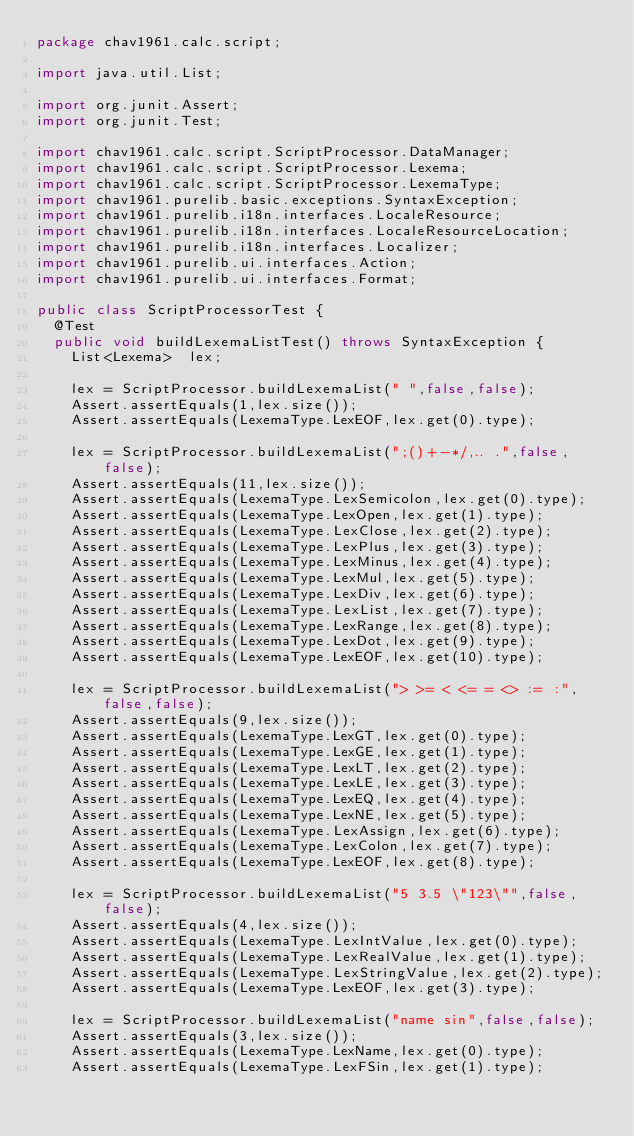<code> <loc_0><loc_0><loc_500><loc_500><_Java_>package chav1961.calc.script;

import java.util.List;

import org.junit.Assert;
import org.junit.Test;

import chav1961.calc.script.ScriptProcessor.DataManager;
import chav1961.calc.script.ScriptProcessor.Lexema;
import chav1961.calc.script.ScriptProcessor.LexemaType;
import chav1961.purelib.basic.exceptions.SyntaxException;
import chav1961.purelib.i18n.interfaces.LocaleResource;
import chav1961.purelib.i18n.interfaces.LocaleResourceLocation;
import chav1961.purelib.i18n.interfaces.Localizer;
import chav1961.purelib.ui.interfaces.Action;
import chav1961.purelib.ui.interfaces.Format;

public class ScriptProcessorTest {
	@Test
	public void buildLexemaListTest() throws SyntaxException {
		List<Lexema>	lex;
		
		lex = ScriptProcessor.buildLexemaList(" ",false,false);
		Assert.assertEquals(1,lex.size());
		Assert.assertEquals(LexemaType.LexEOF,lex.get(0).type);

		lex = ScriptProcessor.buildLexemaList(";()+-*/,.. .",false,false);
		Assert.assertEquals(11,lex.size());
		Assert.assertEquals(LexemaType.LexSemicolon,lex.get(0).type);
		Assert.assertEquals(LexemaType.LexOpen,lex.get(1).type);
		Assert.assertEquals(LexemaType.LexClose,lex.get(2).type);
		Assert.assertEquals(LexemaType.LexPlus,lex.get(3).type);
		Assert.assertEquals(LexemaType.LexMinus,lex.get(4).type);
		Assert.assertEquals(LexemaType.LexMul,lex.get(5).type);
		Assert.assertEquals(LexemaType.LexDiv,lex.get(6).type);
		Assert.assertEquals(LexemaType.LexList,lex.get(7).type);
		Assert.assertEquals(LexemaType.LexRange,lex.get(8).type);
		Assert.assertEquals(LexemaType.LexDot,lex.get(9).type);
		Assert.assertEquals(LexemaType.LexEOF,lex.get(10).type);

		lex = ScriptProcessor.buildLexemaList("> >= < <= = <> := :",false,false);
		Assert.assertEquals(9,lex.size());
		Assert.assertEquals(LexemaType.LexGT,lex.get(0).type);
		Assert.assertEquals(LexemaType.LexGE,lex.get(1).type);
		Assert.assertEquals(LexemaType.LexLT,lex.get(2).type);
		Assert.assertEquals(LexemaType.LexLE,lex.get(3).type);
		Assert.assertEquals(LexemaType.LexEQ,lex.get(4).type);
		Assert.assertEquals(LexemaType.LexNE,lex.get(5).type);
		Assert.assertEquals(LexemaType.LexAssign,lex.get(6).type);
		Assert.assertEquals(LexemaType.LexColon,lex.get(7).type);
		Assert.assertEquals(LexemaType.LexEOF,lex.get(8).type);

		lex = ScriptProcessor.buildLexemaList("5 3.5 \"123\"",false,false);
		Assert.assertEquals(4,lex.size());
		Assert.assertEquals(LexemaType.LexIntValue,lex.get(0).type);
		Assert.assertEquals(LexemaType.LexRealValue,lex.get(1).type);
		Assert.assertEquals(LexemaType.LexStringValue,lex.get(2).type);
		Assert.assertEquals(LexemaType.LexEOF,lex.get(3).type);
		
		lex = ScriptProcessor.buildLexemaList("name sin",false,false);
		Assert.assertEquals(3,lex.size());
		Assert.assertEquals(LexemaType.LexName,lex.get(0).type);
		Assert.assertEquals(LexemaType.LexFSin,lex.get(1).type);</code> 